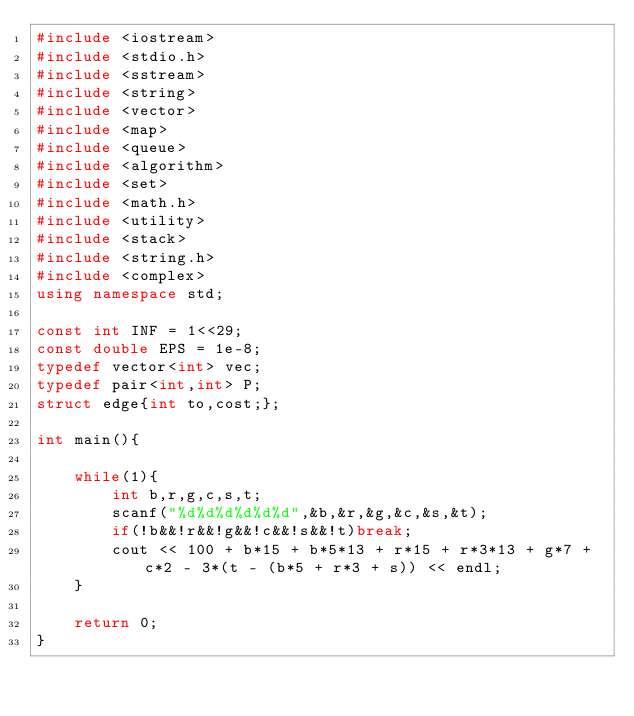<code> <loc_0><loc_0><loc_500><loc_500><_C++_>#include <iostream>
#include <stdio.h>
#include <sstream>
#include <string>
#include <vector>
#include <map>
#include <queue>
#include <algorithm>
#include <set>
#include <math.h>
#include <utility>
#include <stack>
#include <string.h>
#include <complex>
using namespace std;

const int INF = 1<<29;
const double EPS = 1e-8;
typedef vector<int> vec;
typedef pair<int,int> P;
struct edge{int to,cost;};

int main(){

    while(1){
        int b,r,g,c,s,t;
        scanf("%d%d%d%d%d%d",&b,&r,&g,&c,&s,&t);
        if(!b&&!r&&!g&&!c&&!s&&!t)break;
        cout << 100 + b*15 + b*5*13 + r*15 + r*3*13 + g*7 + c*2 - 3*(t - (b*5 + r*3 + s)) << endl;
    }

    return 0;
}</code> 